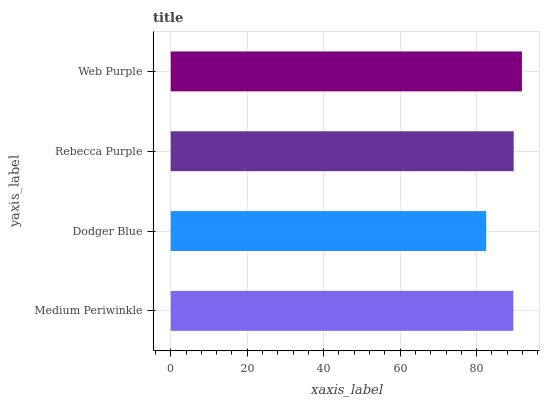Is Dodger Blue the minimum?
Answer yes or no. Yes. Is Web Purple the maximum?
Answer yes or no. Yes. Is Rebecca Purple the minimum?
Answer yes or no. No. Is Rebecca Purple the maximum?
Answer yes or no. No. Is Rebecca Purple greater than Dodger Blue?
Answer yes or no. Yes. Is Dodger Blue less than Rebecca Purple?
Answer yes or no. Yes. Is Dodger Blue greater than Rebecca Purple?
Answer yes or no. No. Is Rebecca Purple less than Dodger Blue?
Answer yes or no. No. Is Rebecca Purple the high median?
Answer yes or no. Yes. Is Medium Periwinkle the low median?
Answer yes or no. Yes. Is Medium Periwinkle the high median?
Answer yes or no. No. Is Web Purple the low median?
Answer yes or no. No. 